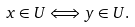Convert formula to latex. <formula><loc_0><loc_0><loc_500><loc_500>x \in U \Longleftrightarrow y \in U .</formula> 